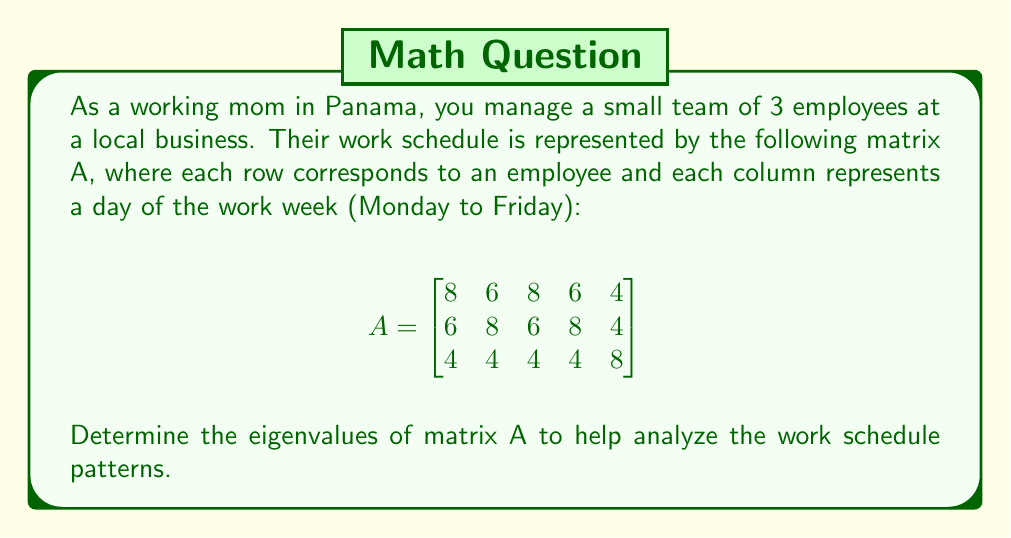What is the answer to this math problem? To find the eigenvalues of matrix A, we need to follow these steps:

1. Calculate the characteristic polynomial:
   $det(A - \lambda I) = 0$, where $I$ is the 3x3 identity matrix.

2. Expand the determinant:
   $$det\begin{bmatrix}
   8-\lambda & 6 & 8 & 6 & 4 \\
   6 & 8-\lambda & 6 & 8 & 4 \\
   4 & 4 & 4-\lambda & 4 & 8
   \end{bmatrix} = 0$$

3. Simplify the characteristic equation:
   $-\lambda^3 + 20\lambda^2 - 32\lambda = 0$

4. Factor the equation:
   $-\lambda(\lambda^2 - 20\lambda + 32) = 0$

5. Solve for $\lambda$:
   $\lambda = 0$ or $\lambda^2 - 20\lambda + 32 = 0$

6. Use the quadratic formula to solve the remaining equation:
   $\lambda = \frac{20 \pm \sqrt{400 - 128}}{2} = \frac{20 \pm \sqrt{272}}{2} = 10 \pm 8\sqrt{2}$

Therefore, the eigenvalues are:
$\lambda_1 = 0$
$\lambda_2 = 10 + 8\sqrt{2}$
$\lambda_3 = 10 - 8\sqrt{2}$
Answer: The eigenvalues of matrix A are:
$\lambda_1 = 0$
$\lambda_2 = 10 + 8\sqrt{2}$
$\lambda_3 = 10 - 8\sqrt{2}$ 